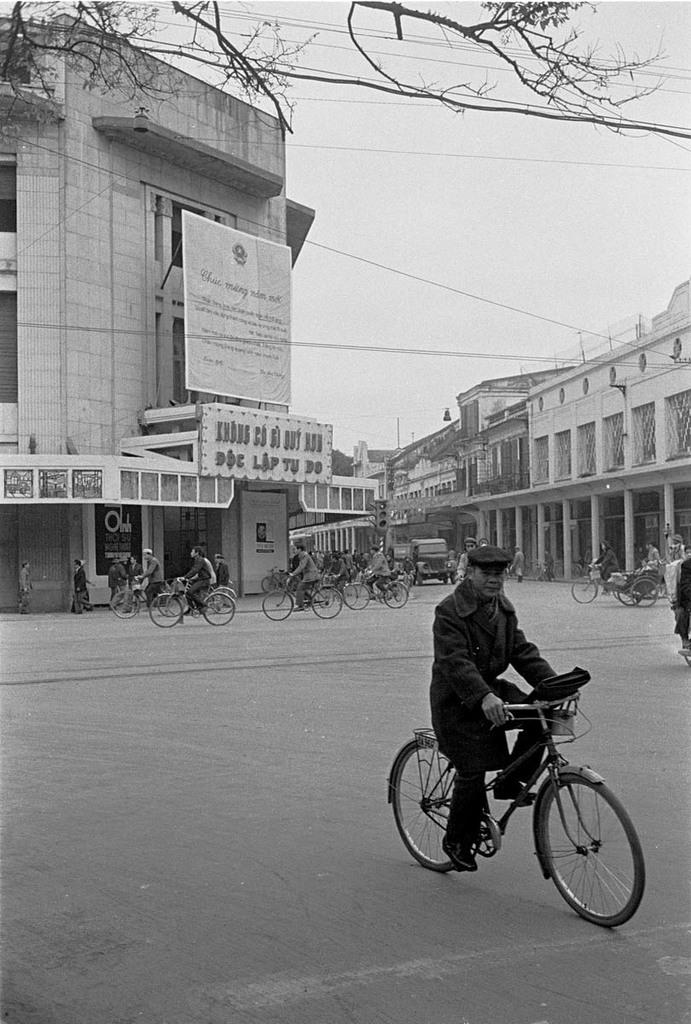How many people are in the image? There is a group of people in the image. What are the people doing in the image? The people are riding bicycles. What can be seen in the background of the image? There are buildings in the background of the image. Is there a bridge made of metal visible in the image? There is no bridge made of metal visible in the image. What type of boundary can be seen separating the people and the buildings? There is no boundary visible in the image that separates the people and the buildings. 